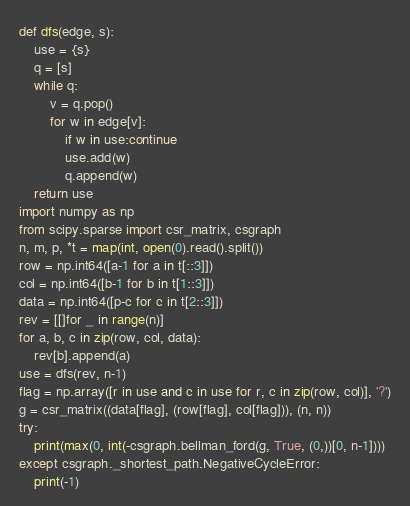<code> <loc_0><loc_0><loc_500><loc_500><_Python_>def dfs(edge, s):
    use = {s}
    q = [s]
    while q:
        v = q.pop()
        for w in edge[v]:
            if w in use:continue
            use.add(w)
            q.append(w)
    return use
import numpy as np
from scipy.sparse import csr_matrix, csgraph
n, m, p, *t = map(int, open(0).read().split())
row = np.int64([a-1 for a in t[::3]])
col = np.int64([b-1 for b in t[1::3]])
data = np.int64([p-c for c in t[2::3]])
rev = [[]for _ in range(n)]
for a, b, c in zip(row, col, data):
    rev[b].append(a)
use = dfs(rev, n-1)
flag = np.array([r in use and c in use for r, c in zip(row, col)], '?')
g = csr_matrix((data[flag], (row[flag], col[flag])), (n, n))
try:
    print(max(0, int(-csgraph.bellman_ford(g, True, (0,))[0, n-1])))
except csgraph._shortest_path.NegativeCycleError:
    print(-1)</code> 